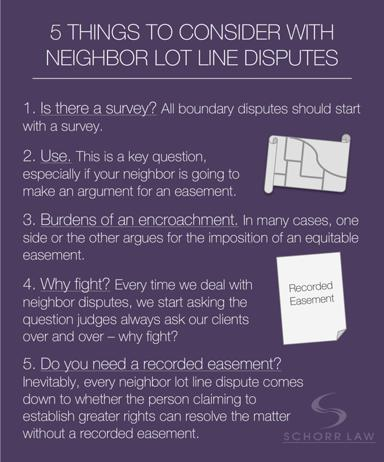What is the first thing to consider in a neighbor lot line dispute, according to the text? The first and foremost step in resolving a neighbor lot line dispute, as outlined in the text, involves conducting a survey. This is crucial because it sets a factual foundation by establishing the precise boundaries of the properties involved. 